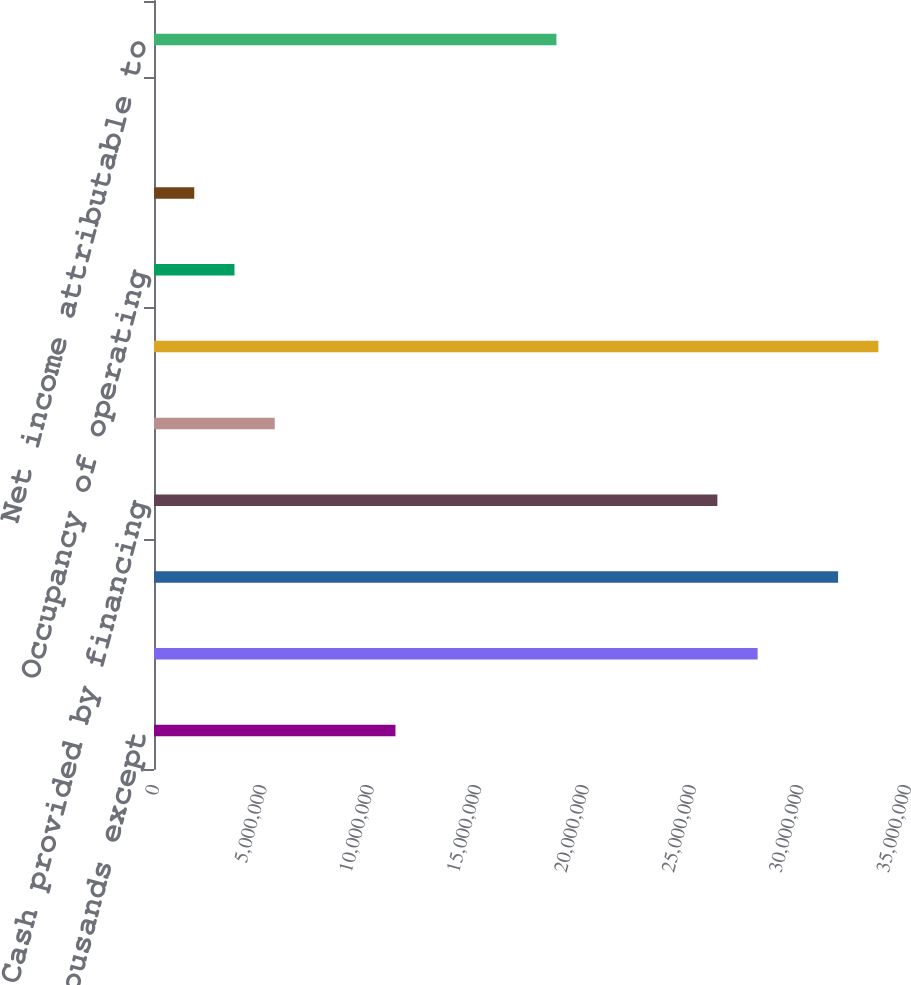Convert chart to OTSL. <chart><loc_0><loc_0><loc_500><loc_500><bar_chart><fcel>(Dollars in thousands except<fcel>Cash provided by operating<fcel>Cash used in investing<fcel>Cash provided by financing<fcel>Number of properties at year<fcel>RSF of properties at year end<fcel>Occupancy of operating<fcel>Occupancy of operating and<fcel>ABR per occupied RSF at year<fcel>Net income attributable to<nl><fcel>1.12376e+07<fcel>2.80939e+07<fcel>3.18398e+07<fcel>2.6221e+07<fcel>5.61881e+06<fcel>3.37127e+07<fcel>3.74589e+06<fcel>1.87296e+06<fcel>37.23<fcel>1.87293e+07<nl></chart> 